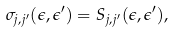<formula> <loc_0><loc_0><loc_500><loc_500>\sigma _ { j , j ^ { \prime } } ( \epsilon , \epsilon ^ { \prime } ) = S _ { j , j ^ { \prime } } ( \epsilon , \epsilon ^ { \prime } ) ,</formula> 